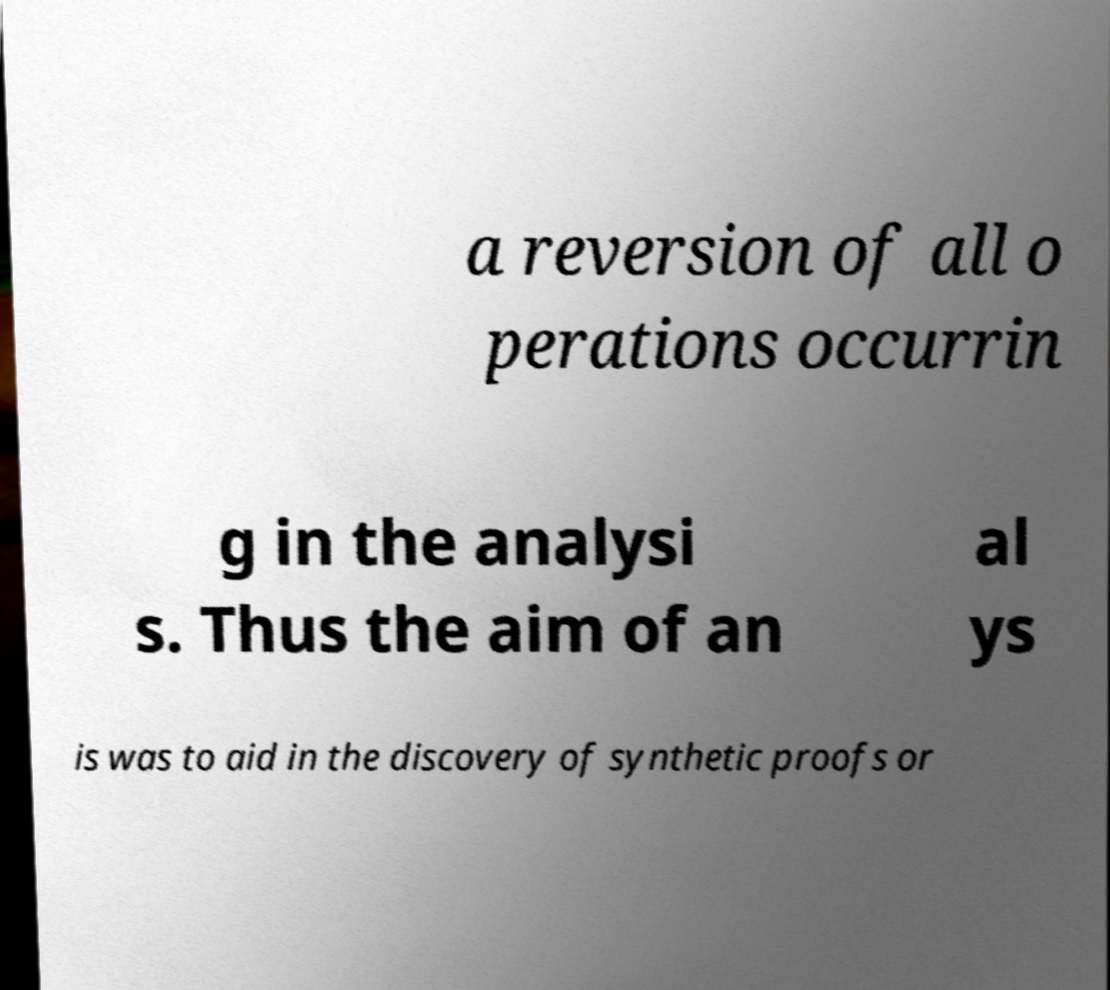There's text embedded in this image that I need extracted. Can you transcribe it verbatim? a reversion of all o perations occurrin g in the analysi s. Thus the aim of an al ys is was to aid in the discovery of synthetic proofs or 